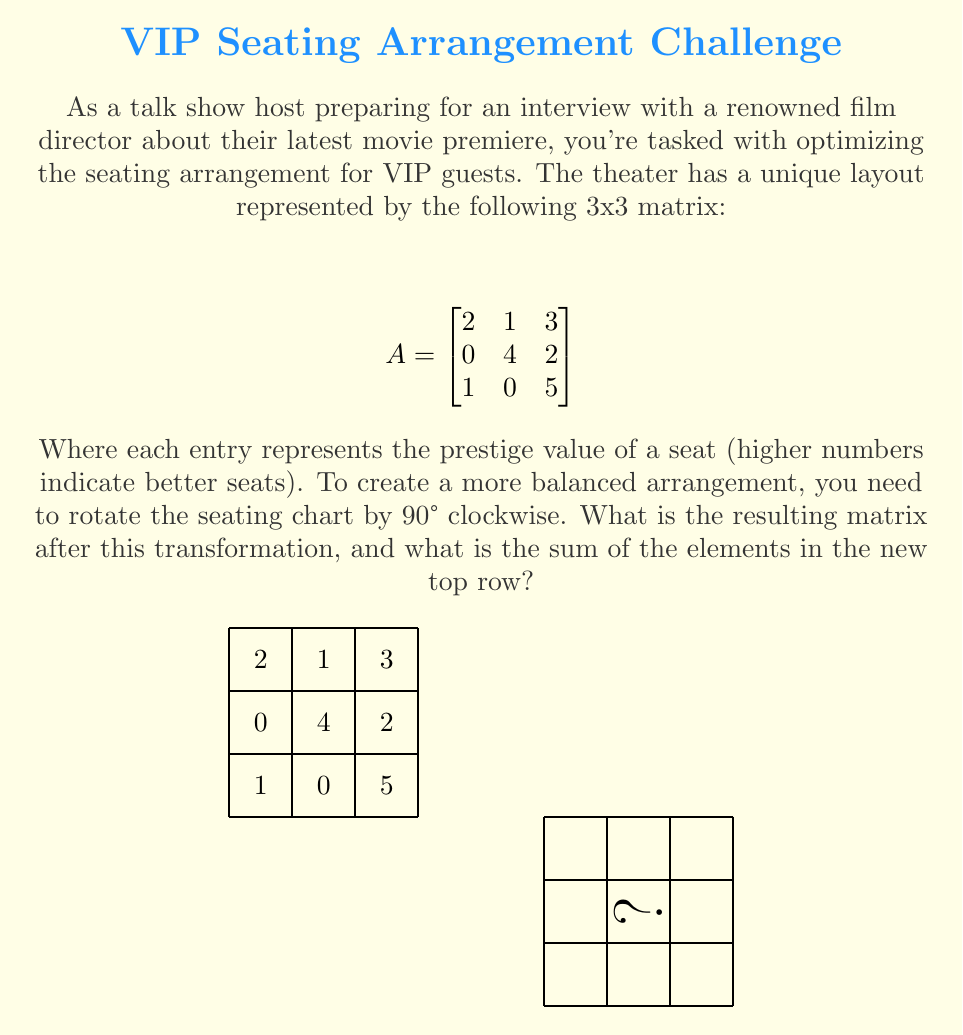Solve this math problem. To solve this problem, we need to perform a 90° clockwise rotation on the given matrix. This rotation can be achieved through matrix transformation. Here's the step-by-step process:

1) For a 3x3 matrix, a 90° clockwise rotation is equivalent to first transposing the matrix and then reversing the order of columns. Let's call our original matrix $A$ and the rotated matrix $B$.

2) First, we transpose matrix $A$:

   $$A^T = \begin{bmatrix}
   2 & 0 & 1 \\
   1 & 4 & 0 \\
   3 & 2 & 5
   \end{bmatrix}$$

3) Now, we reverse the order of columns to get matrix $B$:

   $$B = \begin{bmatrix}
   1 & 0 & 2 \\
   0 & 4 & 1 \\
   5 & 2 & 3
   \end{bmatrix}$$

4) This matrix $B$ represents the new seating arrangement after the 90° clockwise rotation.

5) To find the sum of elements in the new top row, we add the elements of the first row of matrix $B$:

   $1 + 0 + 2 = 3$

Therefore, the sum of the elements in the new top row is 3.
Answer: $$B = \begin{bmatrix}
1 & 0 & 2 \\
0 & 4 & 1 \\
5 & 2 & 3
\end{bmatrix}$$, sum of top row = 3 